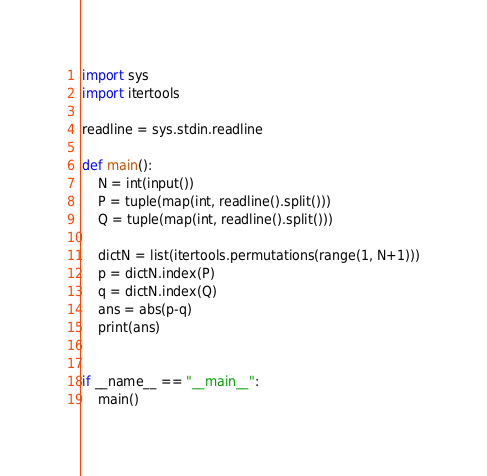<code> <loc_0><loc_0><loc_500><loc_500><_Python_>import sys
import itertools

readline = sys.stdin.readline

def main():
    N = int(input())
    P = tuple(map(int, readline().split()))
    Q = tuple(map(int, readline().split()))
    
    dictN = list(itertools.permutations(range(1, N+1)))
    p = dictN.index(P)
    q = dictN.index(Q)
    ans = abs(p-q)
    print(ans)


if __name__ == "__main__":
    main()
</code> 